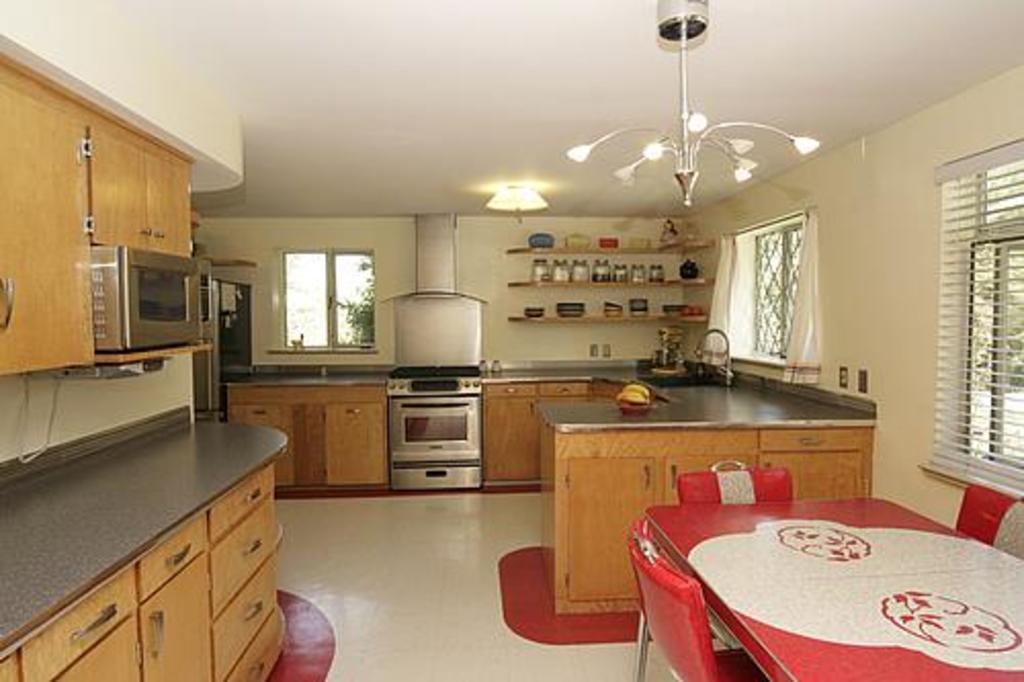Can you describe this image briefly? In this picture I can see the chairs and a dining table and also there are windows on the right side. In the background there is a stove, a sink and a tap. At the top there are lights, on the left side I can see a micro oven and the cupboards. 